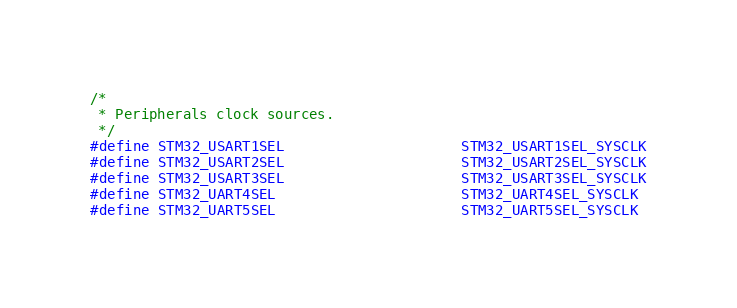Convert code to text. <code><loc_0><loc_0><loc_500><loc_500><_C_>/*
 * Peripherals clock sources.
 */
#define STM32_USART1SEL                     STM32_USART1SEL_SYSCLK
#define STM32_USART2SEL                     STM32_USART2SEL_SYSCLK
#define STM32_USART3SEL                     STM32_USART3SEL_SYSCLK
#define STM32_UART4SEL                      STM32_UART4SEL_SYSCLK
#define STM32_UART5SEL                      STM32_UART5SEL_SYSCLK</code> 